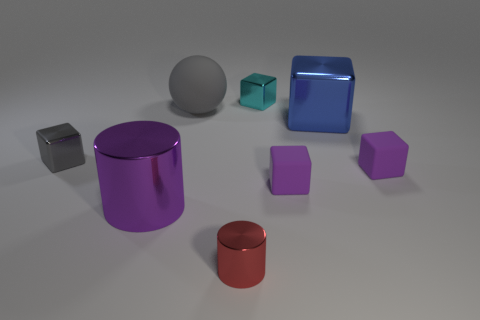There is a shiny block in front of the large object on the right side of the small shiny object behind the gray matte ball; what is its size?
Provide a succinct answer. Small. What number of other things are the same shape as the small cyan shiny object?
Provide a succinct answer. 4. There is a metallic block that is both on the right side of the large sphere and to the left of the big metallic block; what color is it?
Keep it short and to the point. Cyan. Does the tiny metallic cube in front of the blue object have the same color as the rubber ball?
Provide a short and direct response. Yes. How many balls are big purple things or big blue things?
Make the answer very short. 0. What shape is the tiny matte object right of the blue cube?
Provide a succinct answer. Cube. What color is the tiny thing that is to the right of the big shiny thing behind the large thing that is in front of the gray block?
Your answer should be very brief. Purple. Do the small cyan thing and the large blue thing have the same material?
Your answer should be compact. Yes. How many cyan things are either large metal cylinders or tiny matte blocks?
Provide a short and direct response. 0. There is a cyan metal thing; how many small objects are in front of it?
Provide a succinct answer. 4. 